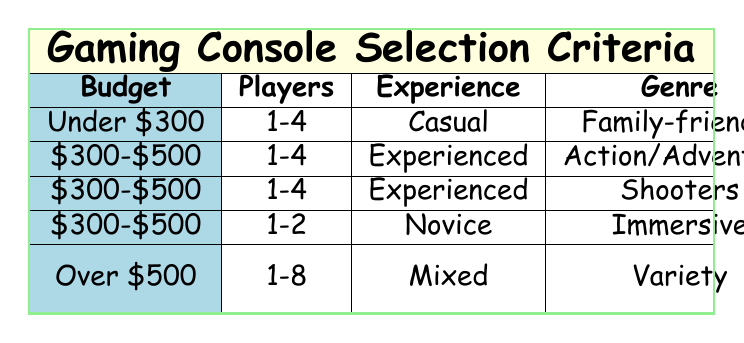What gaming console is recommended for a budget under $300? According to the table, if the budget is under $300, the recommended console is the Nintendo Switch.
Answer: Nintendo Switch Which gaming console requires semi-portability and is suitable for novice players? The table indicates that for novice players who need semi-portability, the recommended console is the Oculus Quest 2.
Answer: Oculus Quest 2 Is it true that the PlayStation 5 is suitable for experiences involving action/adventure genres? Yes, the table clearly states that the PlayStation 5 is suggested for players with experienced gaming backgrounds who prefer action/adventure genres.
Answer: Yes What is the recommended console if someone has a mixed gaming experience and a budget over $500? The table shows that for a mixed gaming experience with a budget over $500, the recommended consoles are both the PlayStation 5 and Nintendo Switch together.
Answer: PlayStation 5 & Nintendo Switch How many players can use the recommended console for casual gaming under a budget of $300? The Nintendo Switch, which is recommended for casual gaming under a budget of $300, allows for 1 to 4 players according to the table.
Answer: 1-4 players What is the average number of players allowed for the consoles listed in the $300-$500 budget range? In the $300-$500 budget range, there are three consoles listed, each allowing for 1-4 players. Therefore, the average number of players can be calculated as follows: (4 + 4 + 4) / 3 = 4.
Answer: 4 Are all consoles capable of supporting 1-2 players? No, based on the table, only the Oculus Quest 2 supports 1-2 players, while the other consoles support 1-4 or more players.
Answer: No Which console provides a family-friendly gaming experience for under $300? The table indicates that the Nintendo Switch is designed for a family-friendly experience and fits the budget criteria of under $300.
Answer: Nintendo Switch 